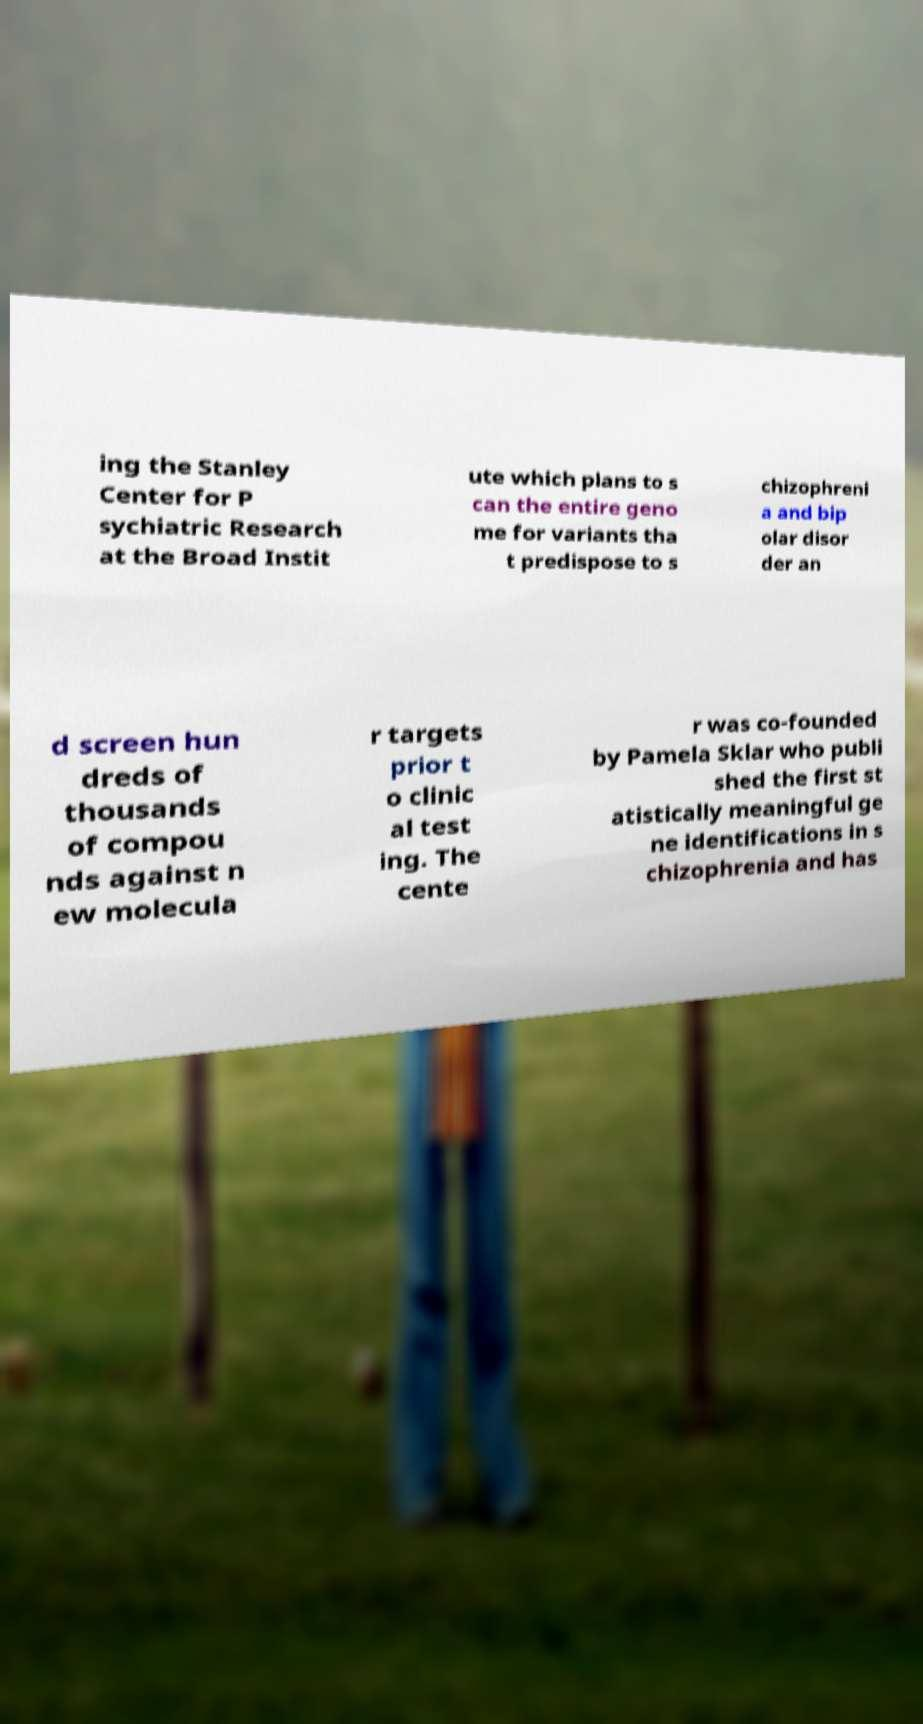I need the written content from this picture converted into text. Can you do that? ing the Stanley Center for P sychiatric Research at the Broad Instit ute which plans to s can the entire geno me for variants tha t predispose to s chizophreni a and bip olar disor der an d screen hun dreds of thousands of compou nds against n ew molecula r targets prior t o clinic al test ing. The cente r was co-founded by Pamela Sklar who publi shed the first st atistically meaningful ge ne identifications in s chizophrenia and has 